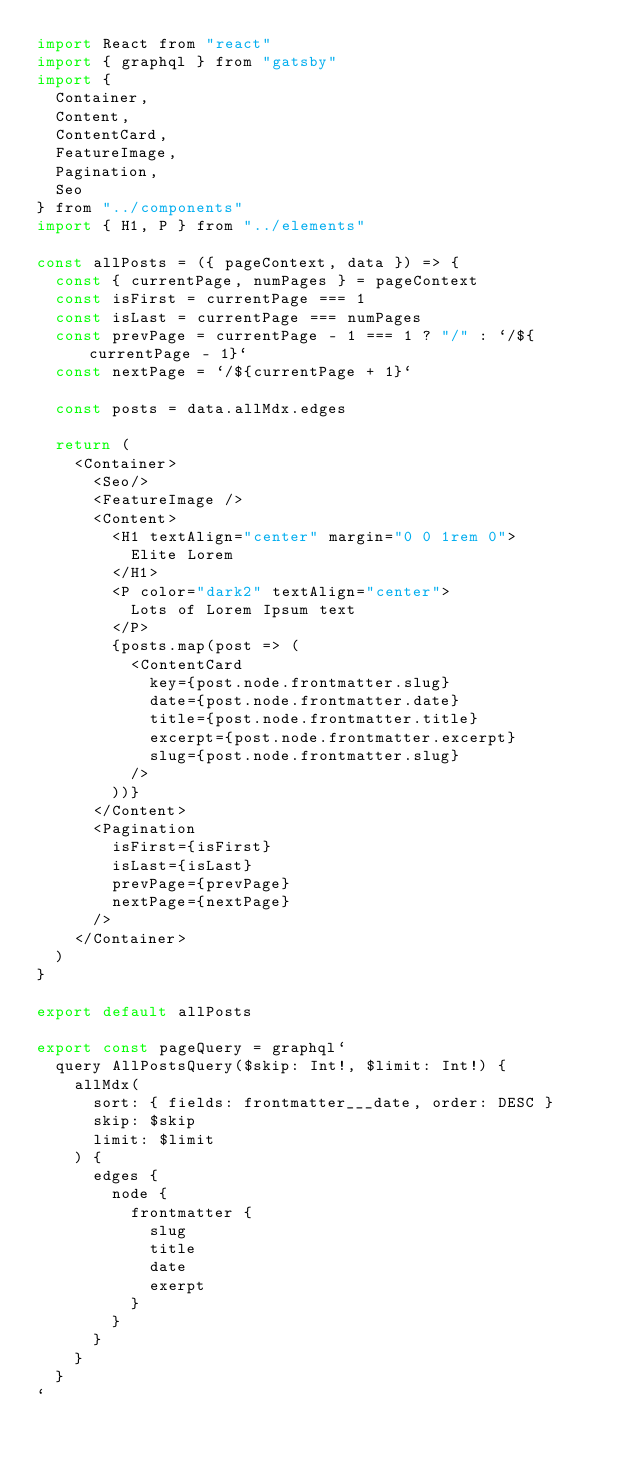Convert code to text. <code><loc_0><loc_0><loc_500><loc_500><_JavaScript_>import React from "react"
import { graphql } from "gatsby"
import {
  Container,
  Content,
  ContentCard,
  FeatureImage,
  Pagination,
  Seo
} from "../components"
import { H1, P } from "../elements"

const allPosts = ({ pageContext, data }) => {
  const { currentPage, numPages } = pageContext
  const isFirst = currentPage === 1
  const isLast = currentPage === numPages
  const prevPage = currentPage - 1 === 1 ? "/" : `/${currentPage - 1}`
  const nextPage = `/${currentPage + 1}`

  const posts = data.allMdx.edges

  return (
    <Container>
      <Seo/>
      <FeatureImage />
      <Content>
        <H1 textAlign="center" margin="0 0 1rem 0">
          Elite Lorem
        </H1>
        <P color="dark2" textAlign="center">
          Lots of Lorem Ipsum text
        </P>
        {posts.map(post => (
          <ContentCard
            key={post.node.frontmatter.slug}
            date={post.node.frontmatter.date}
            title={post.node.frontmatter.title}
            excerpt={post.node.frontmatter.excerpt}
            slug={post.node.frontmatter.slug}
          />
        ))}
      </Content>
      <Pagination
        isFirst={isFirst}
        isLast={isLast}
        prevPage={prevPage}
        nextPage={nextPage}
      />
    </Container>
  )
}

export default allPosts

export const pageQuery = graphql`
  query AllPostsQuery($skip: Int!, $limit: Int!) {
    allMdx(
      sort: { fields: frontmatter___date, order: DESC }
      skip: $skip
      limit: $limit
    ) {
      edges {
        node {
          frontmatter {
            slug
            title
            date
            exerpt
          }
        }
      }
    }
  }
`
</code> 